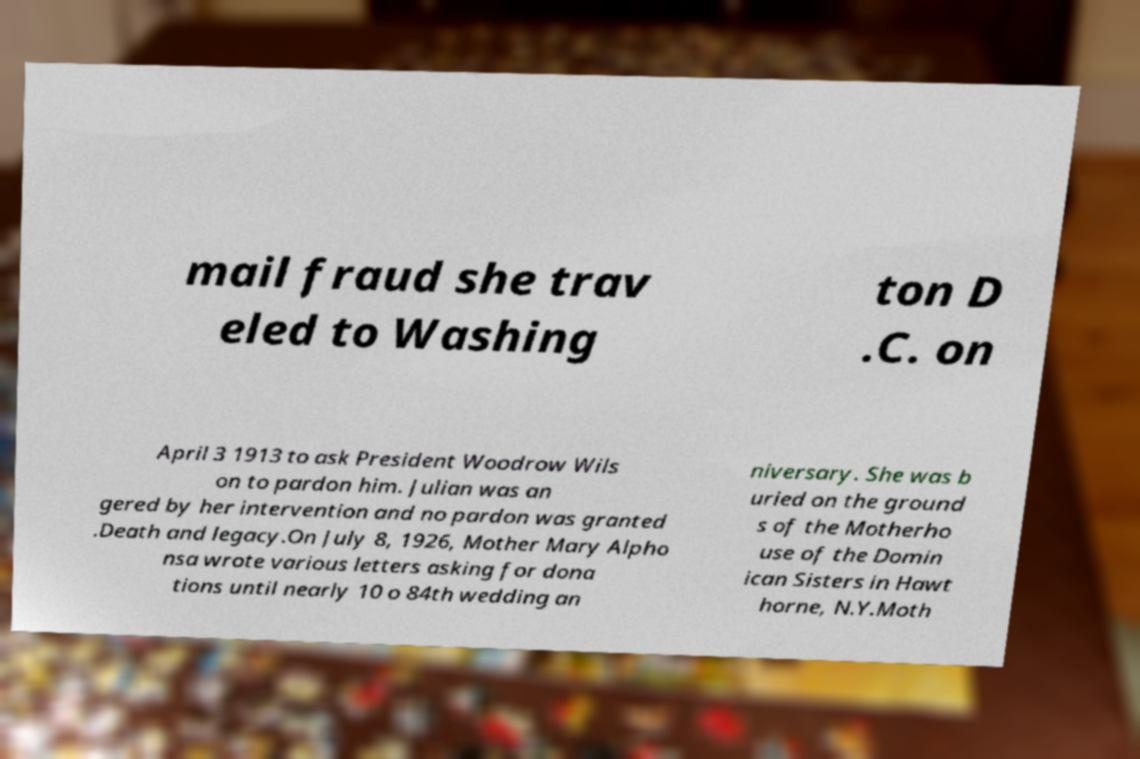For documentation purposes, I need the text within this image transcribed. Could you provide that? mail fraud she trav eled to Washing ton D .C. on April 3 1913 to ask President Woodrow Wils on to pardon him. Julian was an gered by her intervention and no pardon was granted .Death and legacy.On July 8, 1926, Mother Mary Alpho nsa wrote various letters asking for dona tions until nearly 10 o 84th wedding an niversary. She was b uried on the ground s of the Motherho use of the Domin ican Sisters in Hawt horne, N.Y.Moth 